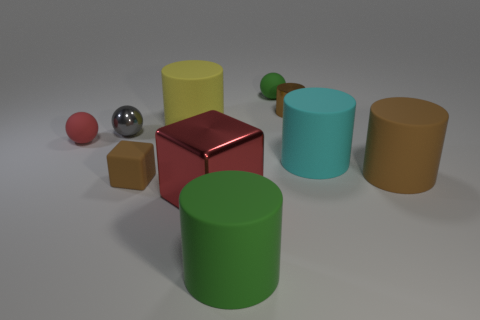Subtract all red balls. How many balls are left? 2 Subtract all green spheres. How many spheres are left? 2 Subtract 3 cylinders. How many cylinders are left? 2 Subtract all spheres. How many objects are left? 7 Subtract all green blocks. How many brown cylinders are left? 2 Subtract all tiny purple shiny cylinders. Subtract all rubber balls. How many objects are left? 8 Add 3 brown rubber objects. How many brown rubber objects are left? 5 Add 3 big green rubber cylinders. How many big green rubber cylinders exist? 4 Subtract 0 blue spheres. How many objects are left? 10 Subtract all yellow balls. Subtract all cyan cylinders. How many balls are left? 3 